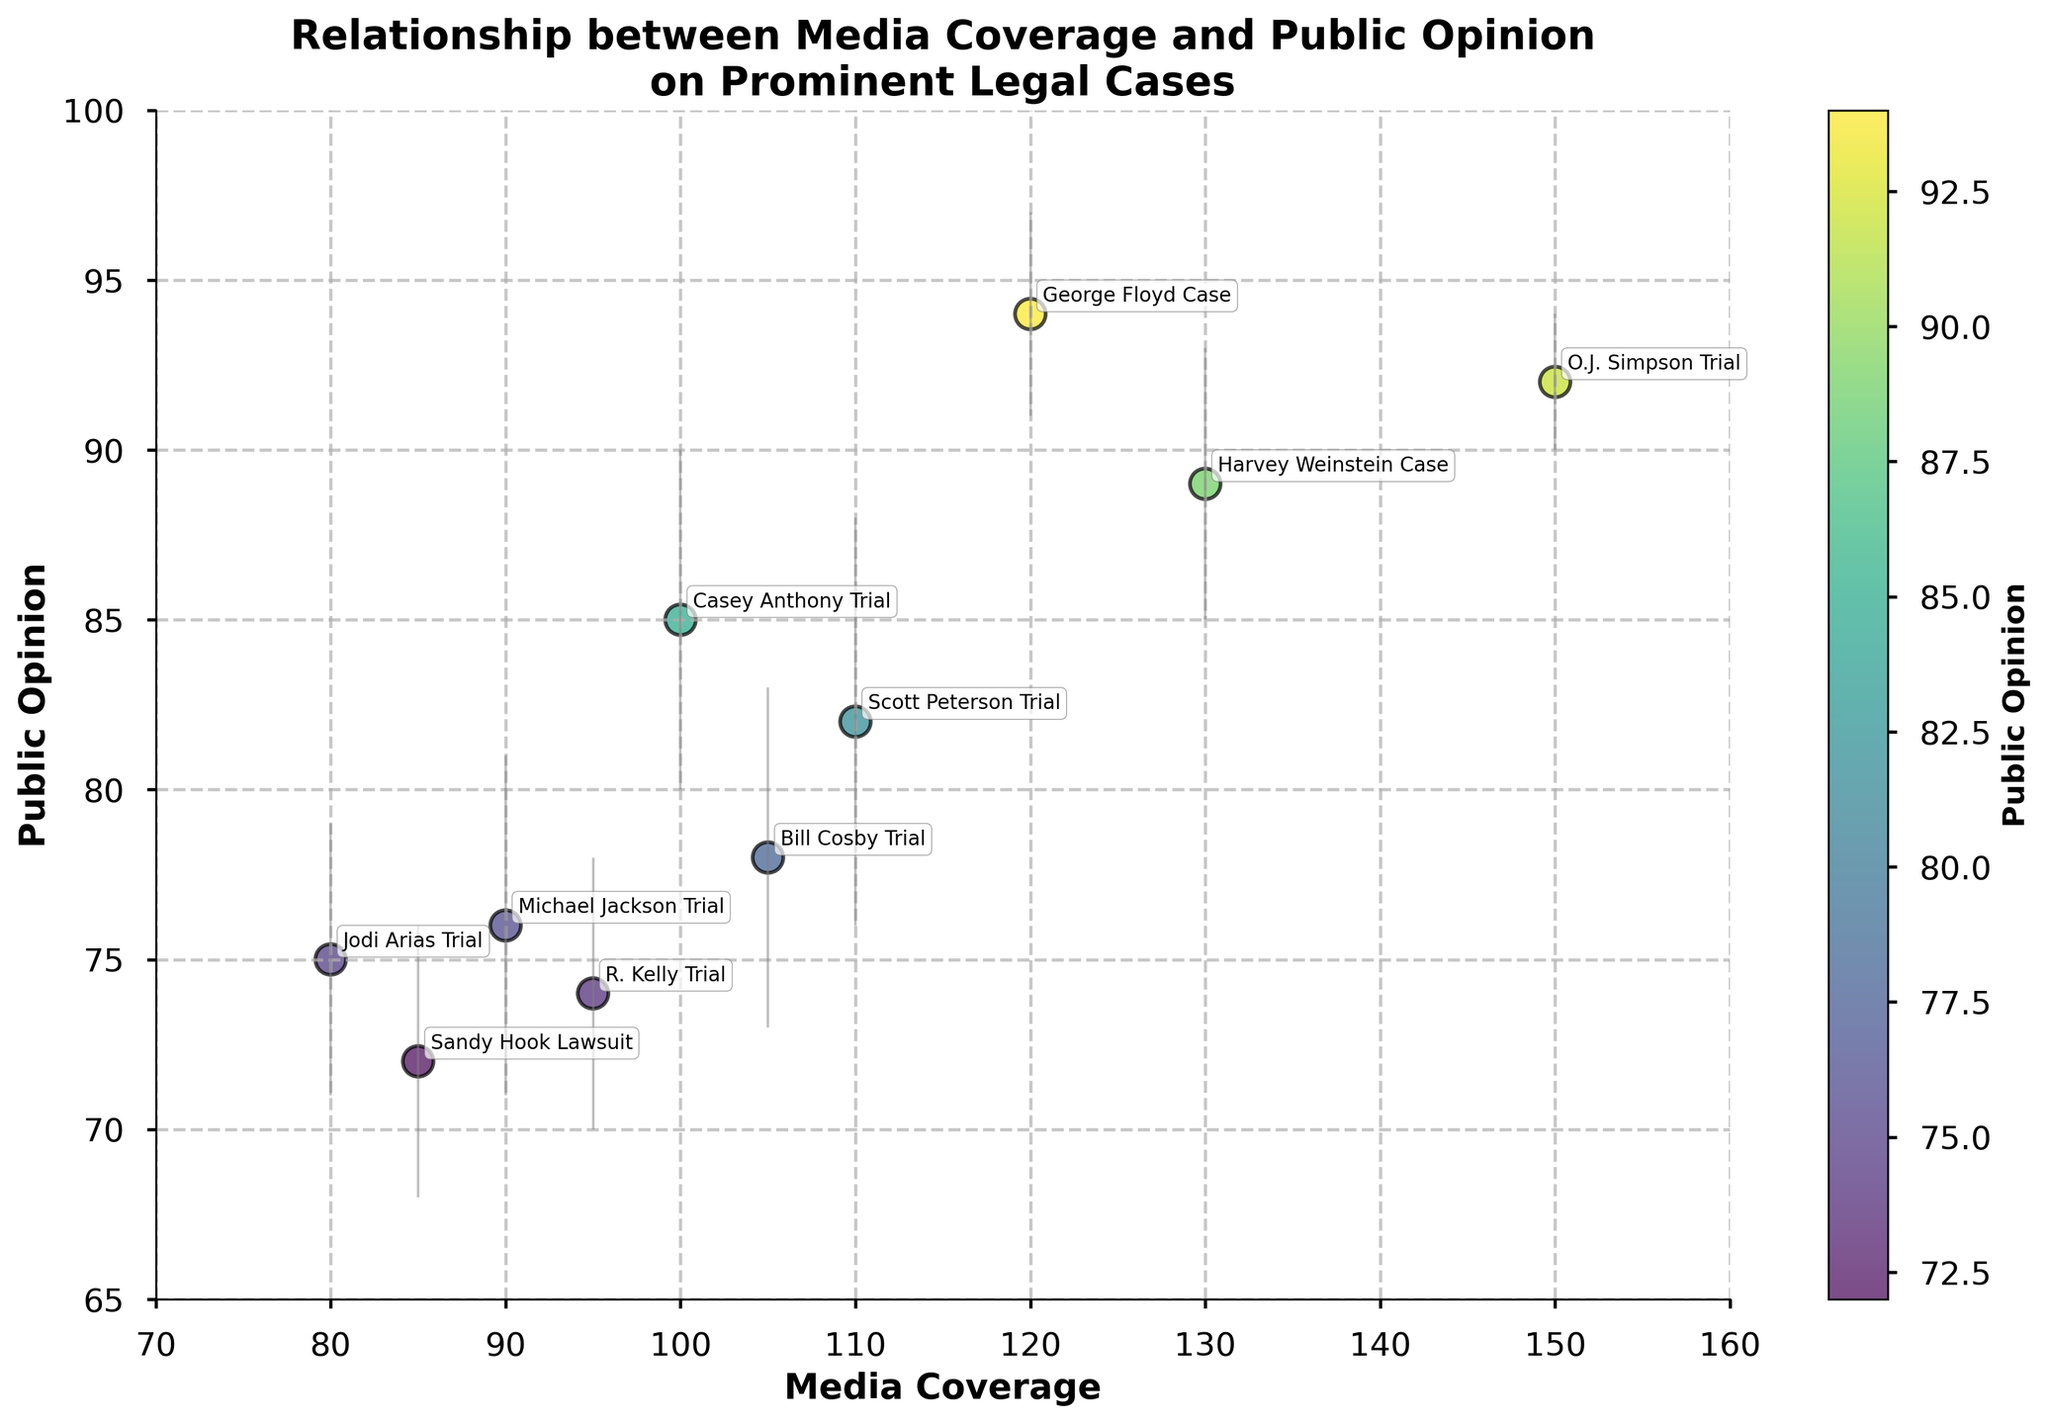What is the title of the figure? The title is displayed at the top of the figure and summarizes the content of the plot. It reads, "Relationship between Media Coverage and Public Opinion on Prominent Legal Cases."
Answer: Relationship between Media Coverage and Public Opinion on Prominent Legal Cases How many data points are shown in the scatter plot? Each point in the scatter plot represents one data case. Counting all the data points reveals there are ten.
Answer: 10 Which case has the highest media coverage? The x-axis represents media coverage. By identifying the farthest point to the right on the x-axis, we see that the "O.J. Simpson Trial" has the highest media coverage at 150.
Answer: O.J. Simpson Trial What is the public opinion value for the George Floyd Case? The public opinion value is represented on the y-axis. By locating the "George Floyd Case" data point, we see its y-coordinate is 94.
Answer: 94 What range of media coverage values is shown on the x-axis? The x-axis label shows the range of media coverage values, which is from approximately 70 to 160.
Answer: 70 to 160 Which case has the largest error margin in public opinion? The error margin is indicated by the length of the error bars extending vertically from the data points. The "Scott Peterson Trial" has the longest error bar, with an error margin of 6.
Answer: Scott Peterson Trial How does the public opinion of the Casey Anthony Trial compare to the Michael Jackson Trial? To compare, note the y-coordinates of both data points. The "Casey Anthony Trial" has a public opinion of 85, whereas the "Michael Jackson Trial" has a public opinion of 76. Hence, the public opinion for the Casey Anthony Trial is higher.
Answer: Casey Anthony Trial is higher Which case has the lowest public opinion value, and what is it? The y-axis represents public opinion. The lowest data point on the y-axis corresponds to the "Sandy Hook Lawsuit," which has a public opinion value of 72.
Answer: Sandy Hook Lawsuit, 72 Is there any visible trend or correlation between media coverage and public opinion? The scatter plot shows that as media coverage increases, public opinion also tends to increase. This suggests a positive correlation between these variables, as indicated by the upward trend of the data points.
Answer: Positive correlation What is the error margin for the Bill Cosby Trial, and how does it compare to the error margin for the O.J. Simpson Trial? The error margin is represented by the length of the error bars. The "Bill Cosby Trial" has an error margin of 5, while the "O.J. Simpson Trial" has an error margin of 2. The Bill Cosby Trial's error margin is larger.
Answer: 5 for Bill Cosby Trial, 2 for O.J. Simpson Trial 